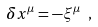Convert formula to latex. <formula><loc_0><loc_0><loc_500><loc_500>\delta x ^ { \mu } = - \xi ^ { \mu } \ ,</formula> 